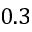Convert formula to latex. <formula><loc_0><loc_0><loc_500><loc_500>0 . 3</formula> 